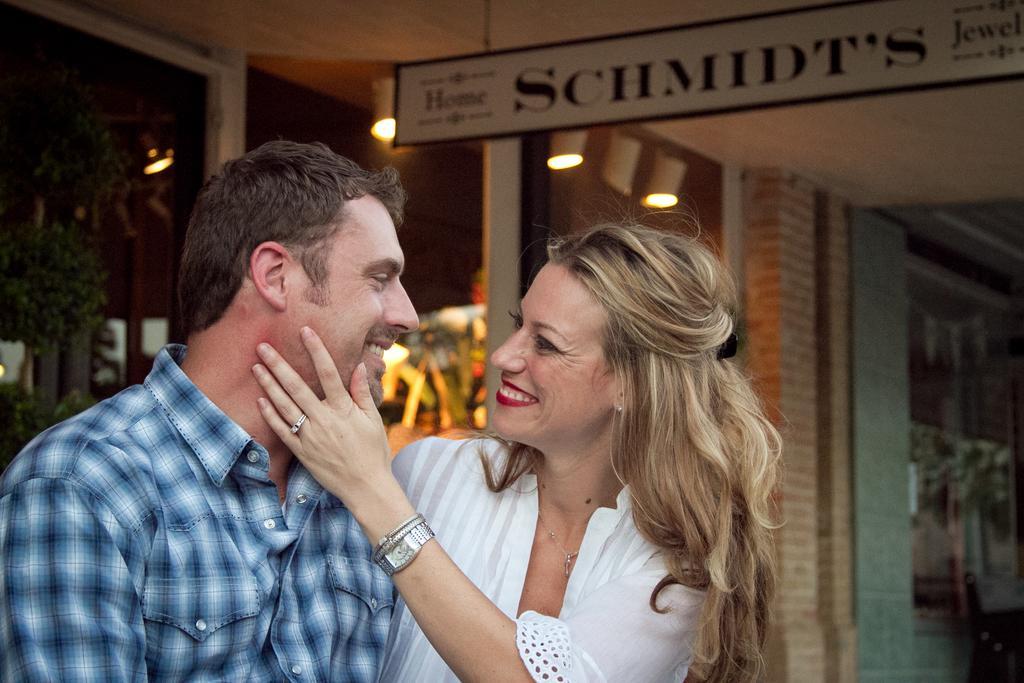Describe this image in one or two sentences. As we can see in the image there is a wall and banner. There are lights, two persons standing in the front and on the left side background there is a tree. The man standing on the left side is wearing blue color shirt. The woman is wearing white color dress. 